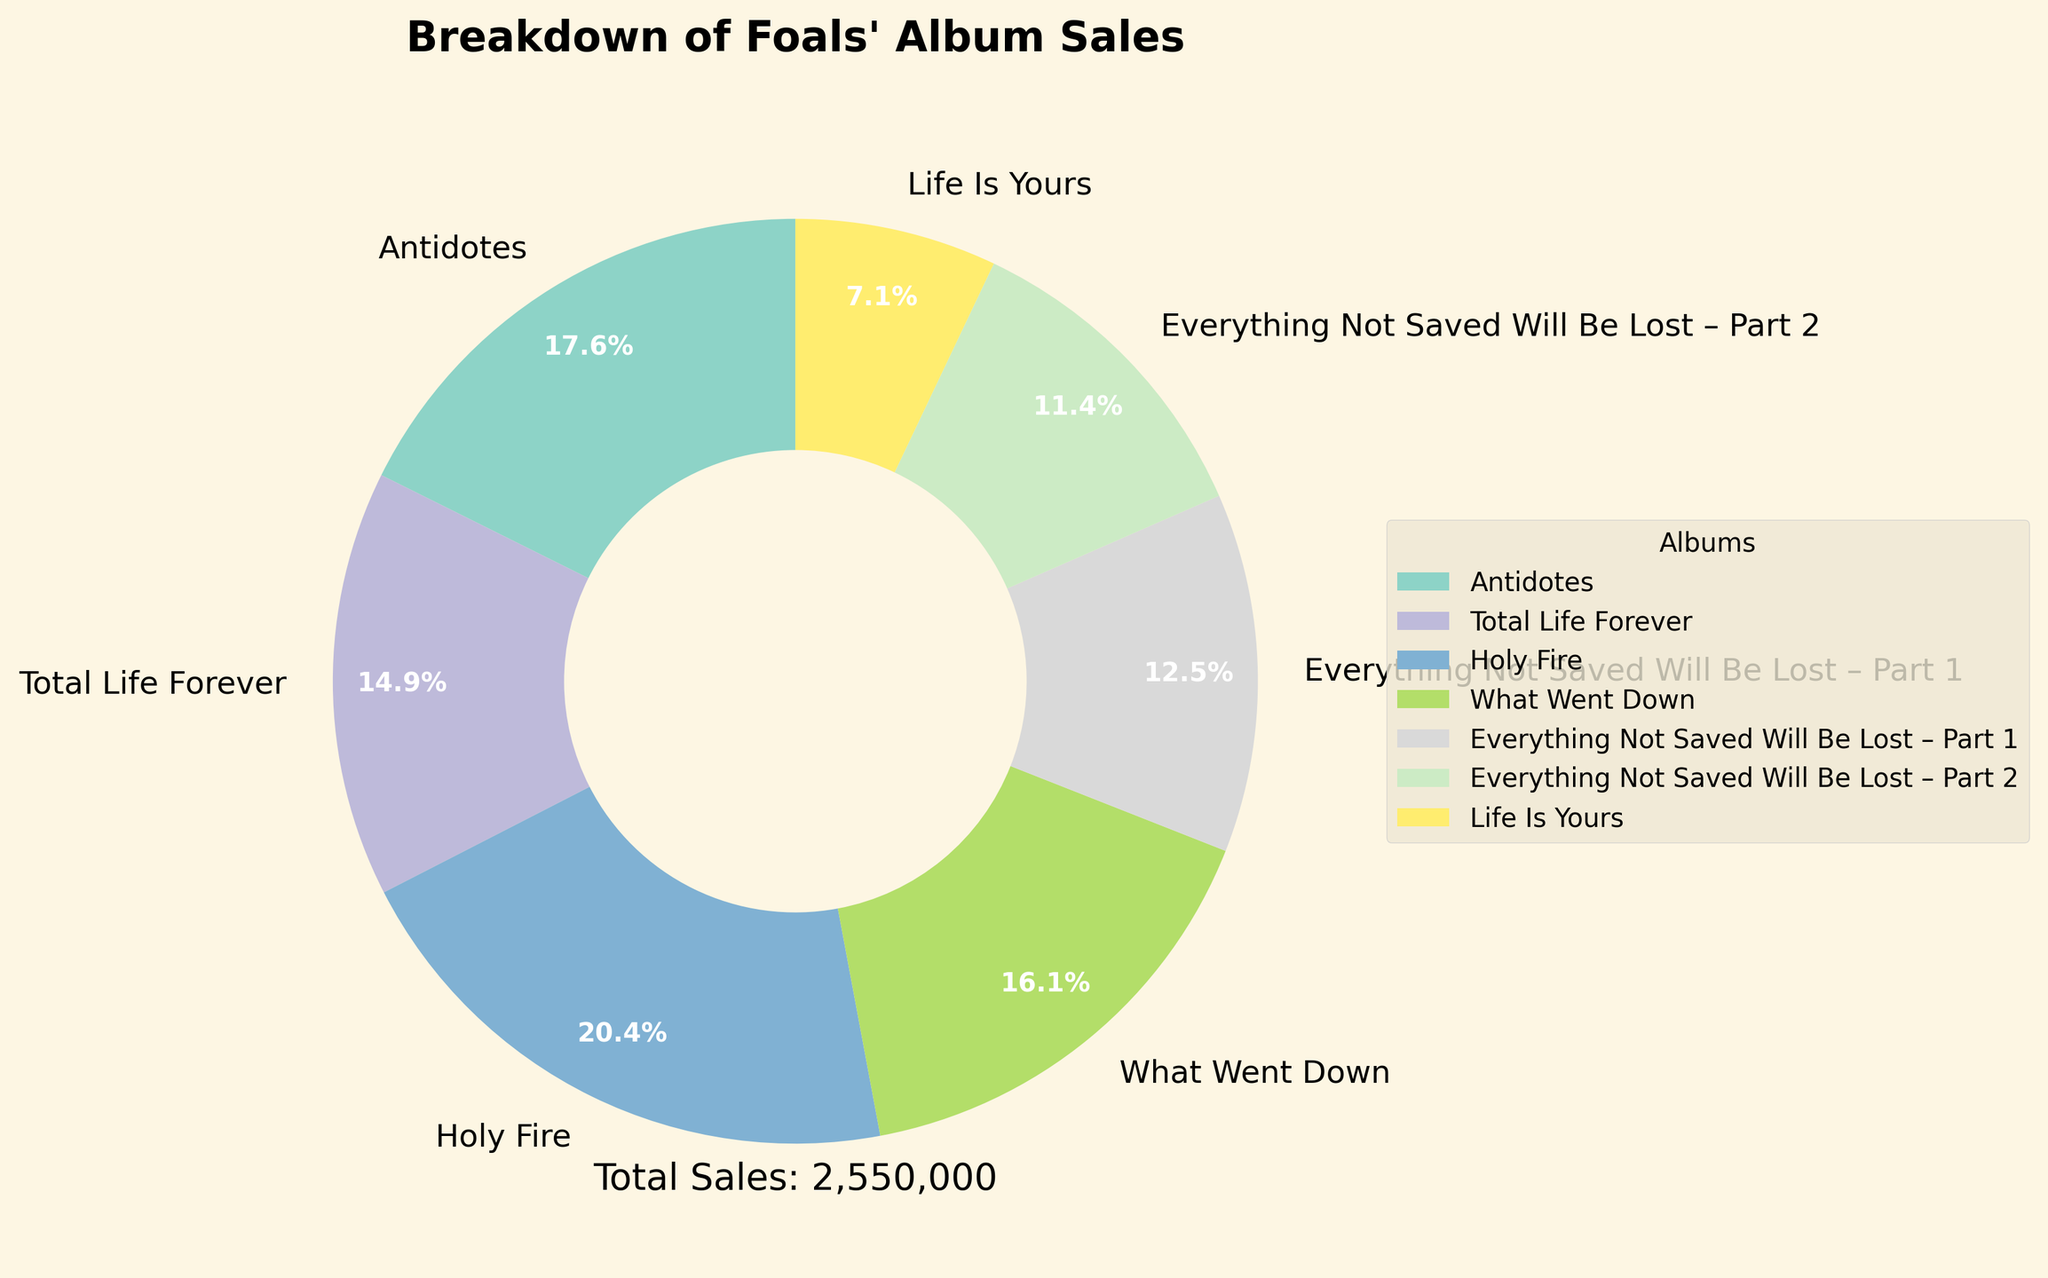What's the album with the highest sales? From the pie chart, we see that "Holy Fire" has the largest wedge, indicating it has the highest sales.
Answer: Holy Fire Which albums together account for more than 50% of the total sales? Adding the percentages from the pie chart, "Holy Fire" (27.4%) and "Antidotes" (23.7%) together make up more than 50%: 27.4% + 23.7% = 51.1%.
Answer: Holy Fire and Antidotes What's the total sales for albums released after "What Went Down"? "Everything Not Saved Will Be Lost – Part 1" (320,000), "Everything Not Saved Will Be Lost – Part 2" (290,000), and "Life Is Yours" (180,000) together sum up to 320,000 + 290,000 + 180,000 = 790,000.
Answer: 790,000 Which album has the smallest sales? By looking at the size of the wedges, "Life Is Yours" has the smallest wedge, indicating it has the smallest sales.
Answer: Life Is Yours Compare the sales of "Total Life Forever" and "What Went Down". Which is higher and by how much? "What Went Down" (410,000) is higher compared to "Total Life Forever" (380,000) by 410,000 - 380,000 = 30,000.
Answer: What Went Down, 30,000 What's the combined percentage of sales for the first two albums? The first two albums, "Antidotes" (23.7%) and "Total Life Forever" (20.0%), combined for 23.7% + 20.0% = 43.7%.
Answer: 43.7% Which albums fall into the middle 50% of total sales? The albums starting with the second and ending with the fifth in the list sorted by sales constitute the middle 50%. These albums are "Total Life Forever," "What Went Down," and "Everything Not Saved Will Be Lost – Part 1".
Answer: Total Life Forever, What Went Down, Everything Not Saved Will Be Lost – Part 1 What portion of the total sales does "Everything Not Saved Will Be Lost – Part 1" and "Everything Not Saved Will Be Lost – Part 2" together represent? From the pie chart, "Everything Not Saved Will Be Lost – Part 1" is 16.8% and "Everything Not Saved Will Be Lost – Part 2" is 15.2%, so combined they are 16.8% + 15.2% = 32%.
Answer: 32% How do the sales of "Life Is Yours" compare visually to other albums? The wedge for "Life Is Yours" is notably smaller compared to other albums, indicating much lower sales visually.
Answer: Smaller What's the percentage difference between the highest and lowest selling albums? The highest selling album "Holy Fire" has 27.4% and the lowest "Life Is Yours" has 9.5%, so the difference is 27.4% - 9.5% = 17.9%.
Answer: 17.9% 